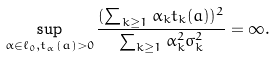Convert formula to latex. <formula><loc_0><loc_0><loc_500><loc_500>\sup _ { \alpha \in \ell _ { 0 } , t _ { \alpha } ( a ) > 0 } \frac { ( \sum _ { k \geq 1 } \alpha _ { k } t _ { k } ( a ) ) ^ { 2 } } { \sum _ { k \geq 1 } \alpha _ { k } ^ { 2 } \sigma _ { k } ^ { 2 } } = \infty .</formula> 